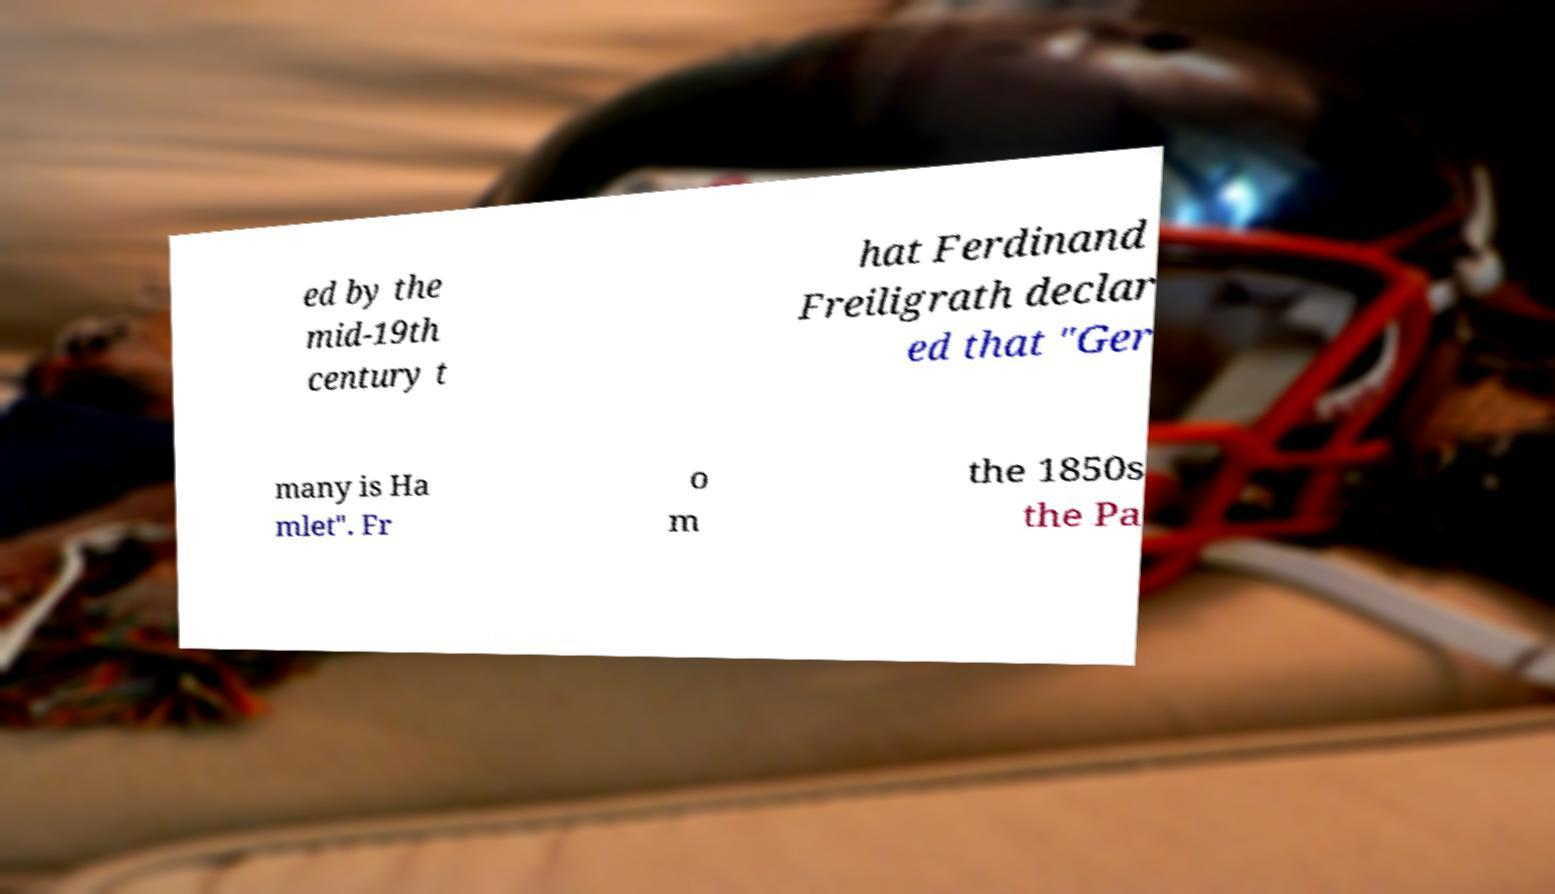I need the written content from this picture converted into text. Can you do that? ed by the mid-19th century t hat Ferdinand Freiligrath declar ed that "Ger many is Ha mlet". Fr o m the 1850s the Pa 